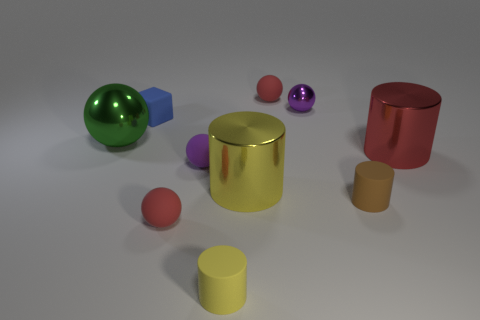Subtract all brown cylinders. How many cylinders are left? 3 Subtract all red shiny cylinders. How many cylinders are left? 3 Subtract all cubes. How many objects are left? 9 Subtract 1 spheres. How many spheres are left? 4 Add 3 small purple cylinders. How many small purple cylinders exist? 3 Subtract 0 brown balls. How many objects are left? 10 Subtract all green balls. Subtract all cyan cylinders. How many balls are left? 4 Subtract all brown balls. How many green cubes are left? 0 Subtract all big gray blocks. Subtract all cylinders. How many objects are left? 6 Add 6 red rubber things. How many red rubber things are left? 8 